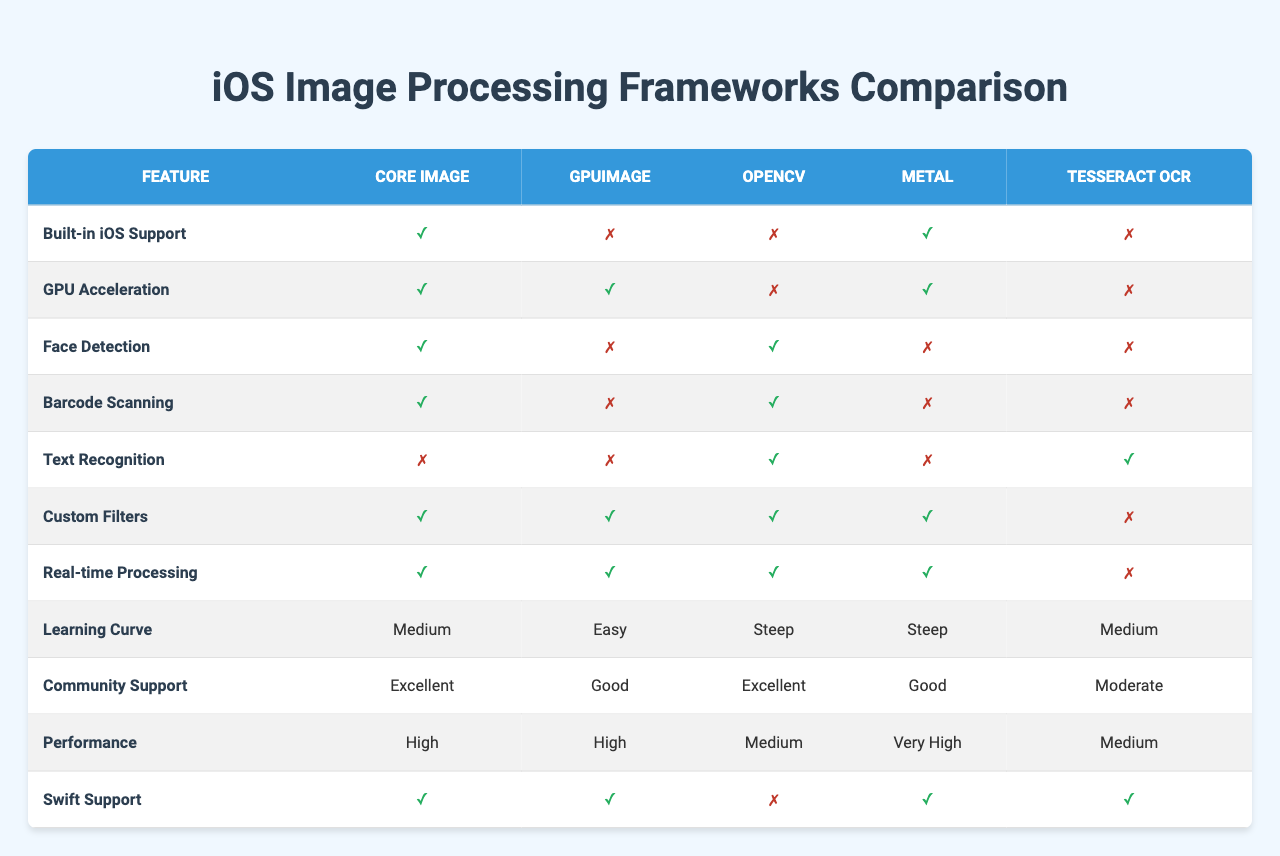What frameworks have built-in iOS support? By looking at the table, we can see the "Built-in iOS Support" feature, which indicates which frameworks have this capability marked as true. The frameworks with built-in iOS support are Core Image and Metal.
Answer: Core Image, Metal Which framework offers the best community support? The "Community Support" row shows varying ratings for each framework. Core Image and OpenCV are rated as "Excellent," which is the highest rating available.
Answer: Core Image, OpenCV How many frameworks have GPU acceleration capabilities? We can check the "GPU Acceleration" feature and see which frameworks are marked as true. Both Core Image and GPUImage, along with Metal, provide GPU acceleration. This totals to 3 frameworks.
Answer: 3 Does Tesseract OCR support real-time processing? Referring to the "Real-time Processing" row, Tesseract OCR is marked as false, indicating it does not support this feature.
Answer: No Which framework has the steepest learning curve? The "Learning Curve" section shows that OpenCV and Metal are marked as "Steep," making them the frameworks with the steepest learning curve.
Answer: OpenCV, Metal How does the performance of Metal compare to that of Core Image? Looking at the "Performance" row, Metal has a rating of "Very High" while Core Image is rated as "High." Thus, Metal performs better than Core Image.
Answer: Metal performs better Which framework offers custom filters but lacks text recognition? By reviewing the "Custom Filters" and "Text Recognition" features, we see that Core Image, GPUImage, and OpenCV provide custom filters while Tesseract OCR lacks text recognition.
Answer: Tesseract OCR What percentage of frameworks have face detection capabilities? There are 5 frameworks in total, and 3 of them (Core Image, OpenCV) have face detection capabilities. Therefore, the percentage is (3/5) * 100 = 60%.
Answer: 60% Is there a framework that supports Swift but does not have built-in iOS support? By examining both the "Swift Support" and "Built-in iOS Support" features, we find that GPUImage supports Swift but does not have built-in iOS support.
Answer: Yes Which frameworks support both custom filters and real-time processing? Checking the "Custom Filters" and "Real-time Processing" features, we find that Core Image, GPUImage, OpenCV, and Metal all support both.
Answer: Core Image, GPUImage, OpenCV, Metal What is the average learning curve rating for all frameworks? Converting the learning curve ratings to a scale: Medium=1, Easy=0, Steep=2, the calculations are: (Medium(1) + Easy(0) + Steep(2) + Steep(2) + Medium(1)) / 5 = 1.2. Since the average isn’t a direct scale rating, we classify it closer to Medium.
Answer: Medium 